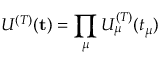Convert formula to latex. <formula><loc_0><loc_0><loc_500><loc_500>U ^ { ( T ) } ( t ) = \prod _ { \mu } U _ { \mu } ^ { ( T ) } ( t _ { \mu } )</formula> 